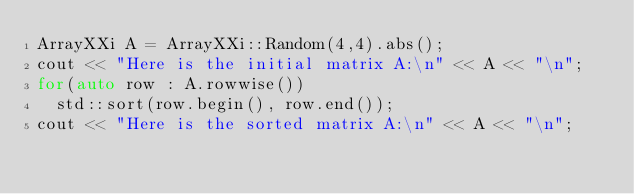Convert code to text. <code><loc_0><loc_0><loc_500><loc_500><_C++_>ArrayXXi A = ArrayXXi::Random(4,4).abs();
cout << "Here is the initial matrix A:\n" << A << "\n";
for(auto row : A.rowwise())
  std::sort(row.begin(), row.end());
cout << "Here is the sorted matrix A:\n" << A << "\n";
</code> 